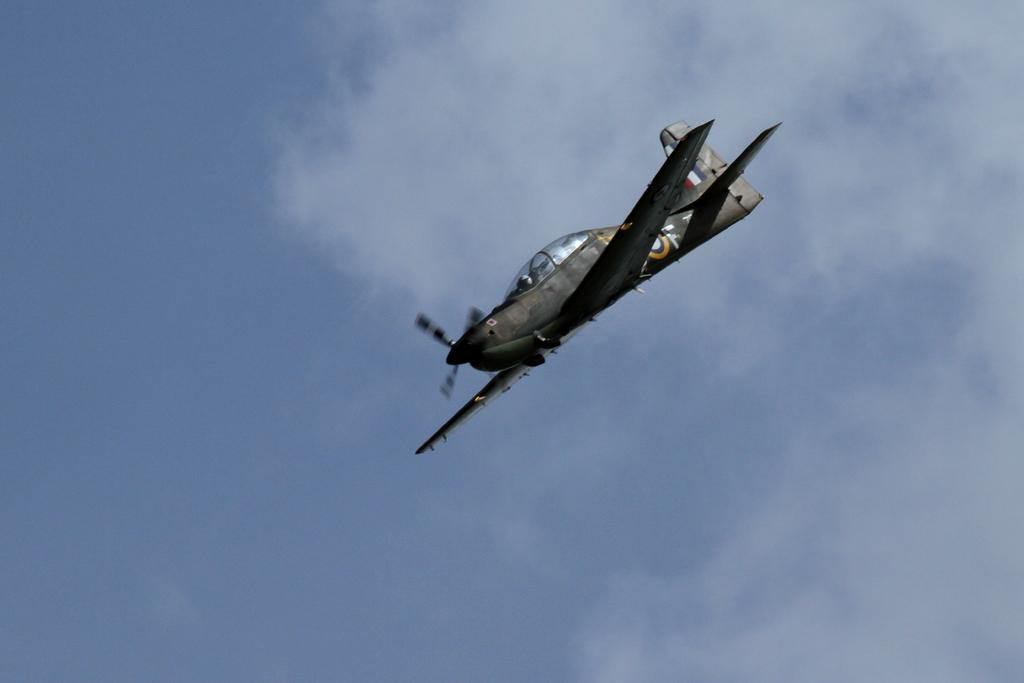Who is present in the image? There is a man in the image. What is the man wearing on his head? The man is wearing a helmet. Where is the man located in the image? The man is sitting inside a plane. What can be seen outside the plane in the image? Sky is visible in the image, and clouds are present in the sky. Are there any giants visible in the image? No, there are no giants present in the image. What type of pocket can be seen on the man's helmet? There is no pocket visible on the man's helmet in the image. 